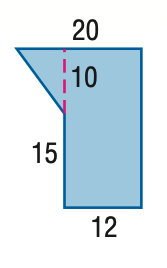Question: Find the area of the figure. Round to the nearest tenth if necessary.
Choices:
A. 230
B. 300
C. 340
D. 400
Answer with the letter. Answer: C 